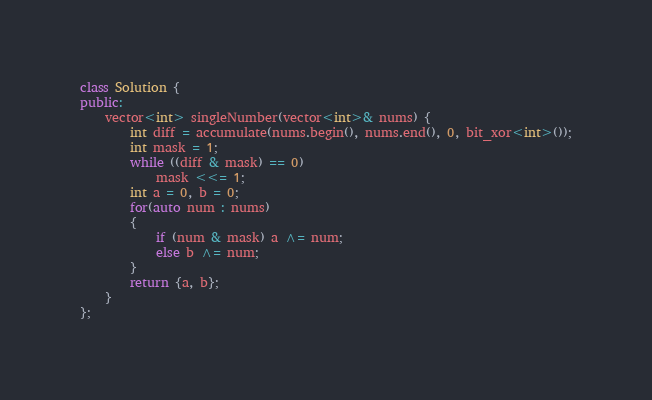<code> <loc_0><loc_0><loc_500><loc_500><_C++_>class Solution {
public:
    vector<int> singleNumber(vector<int>& nums) {
        int diff = accumulate(nums.begin(), nums.end(), 0, bit_xor<int>());
        int mask = 1;
        while ((diff & mask) == 0)
            mask <<= 1;
        int a = 0, b = 0;
        for(auto num : nums)
        {
            if (num & mask) a ^= num;
            else b ^= num;
        }
        return {a, b};
    }
};</code> 